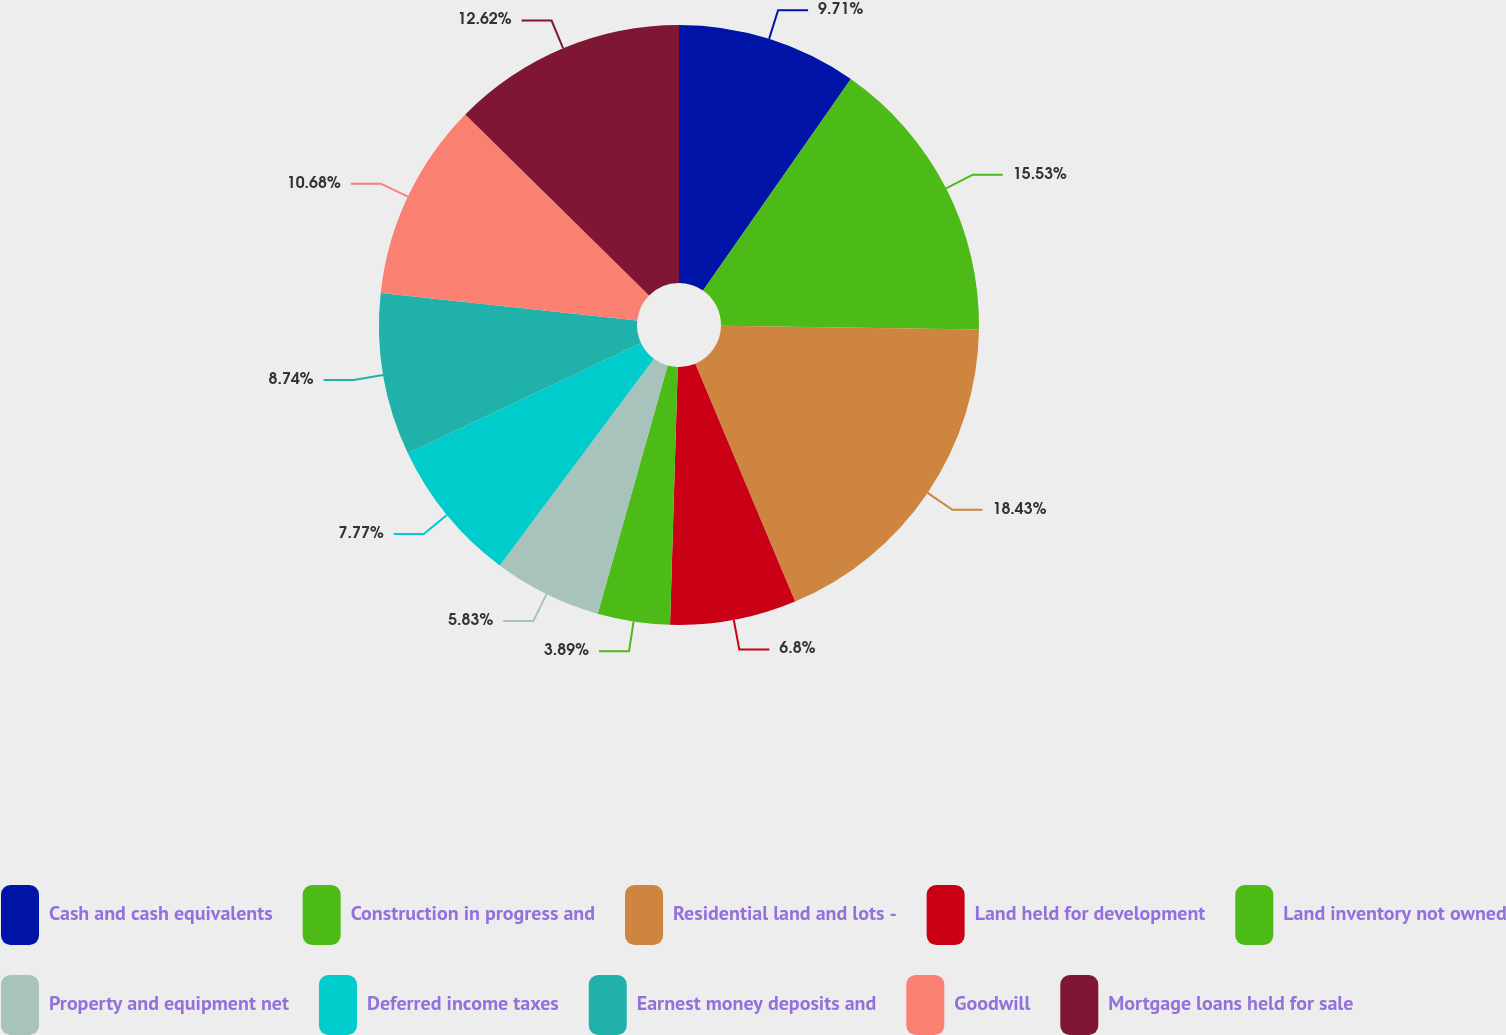<chart> <loc_0><loc_0><loc_500><loc_500><pie_chart><fcel>Cash and cash equivalents<fcel>Construction in progress and<fcel>Residential land and lots -<fcel>Land held for development<fcel>Land inventory not owned<fcel>Property and equipment net<fcel>Deferred income taxes<fcel>Earnest money deposits and<fcel>Goodwill<fcel>Mortgage loans held for sale<nl><fcel>9.71%<fcel>15.53%<fcel>18.44%<fcel>6.8%<fcel>3.89%<fcel>5.83%<fcel>7.77%<fcel>8.74%<fcel>10.68%<fcel>12.62%<nl></chart> 